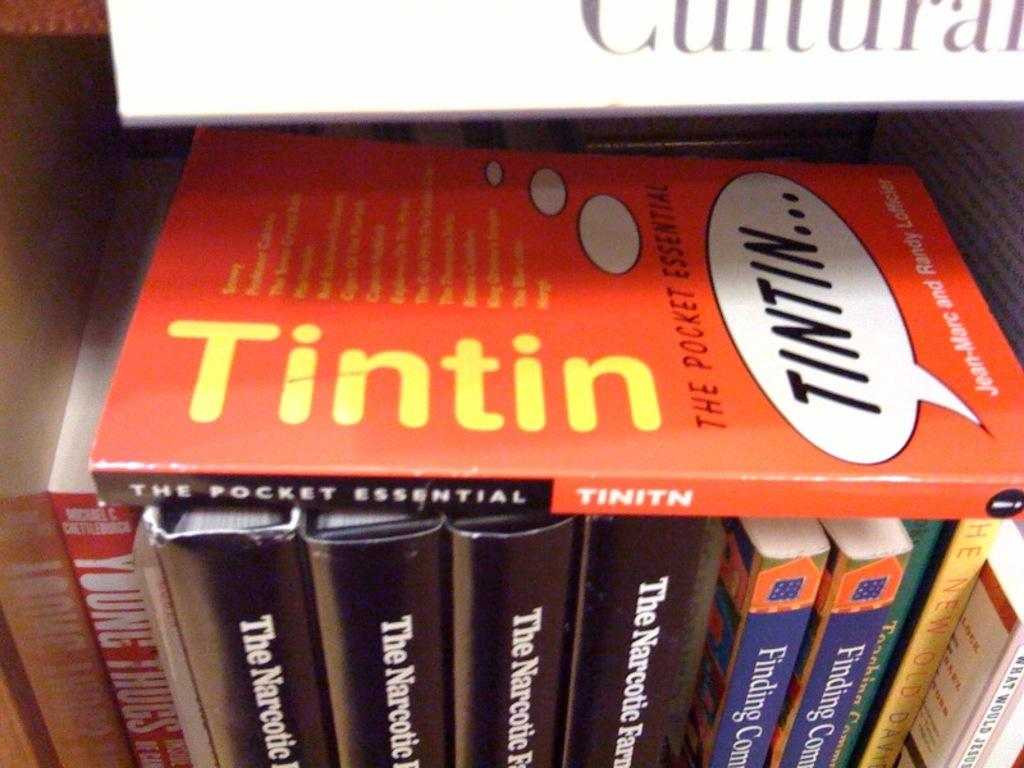Provide a one-sentence caption for the provided image. The book, "Tintin" is on top of several other books. 